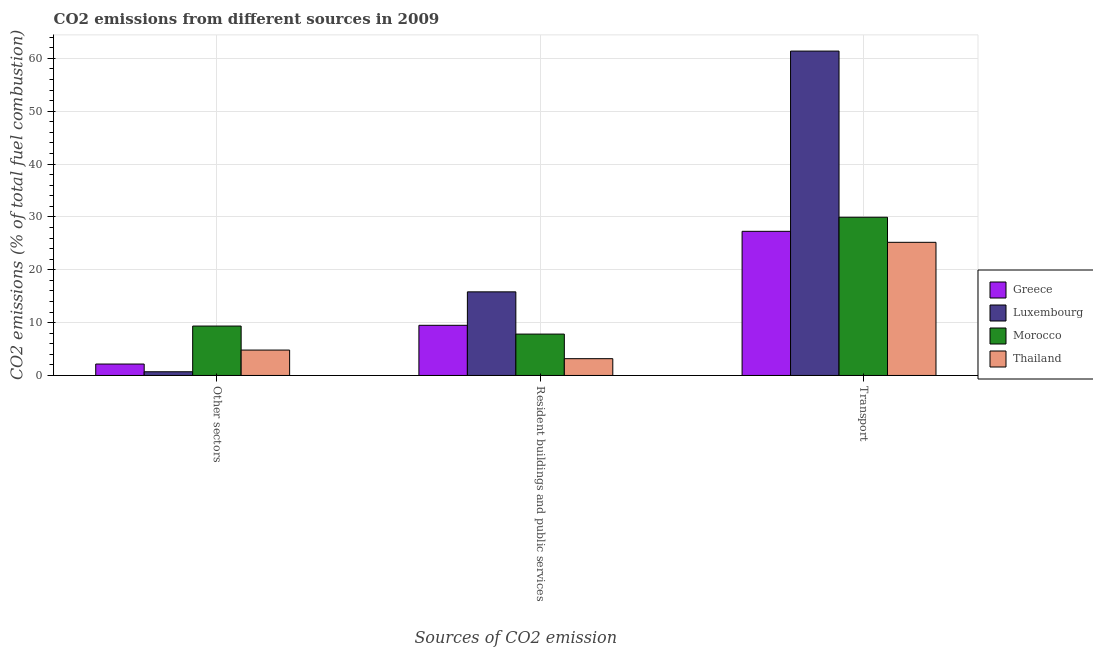How many different coloured bars are there?
Provide a succinct answer. 4. Are the number of bars per tick equal to the number of legend labels?
Your response must be concise. Yes. How many bars are there on the 2nd tick from the right?
Provide a short and direct response. 4. What is the label of the 2nd group of bars from the left?
Keep it short and to the point. Resident buildings and public services. What is the percentage of co2 emissions from transport in Luxembourg?
Ensure brevity in your answer.  61.36. Across all countries, what is the maximum percentage of co2 emissions from transport?
Provide a short and direct response. 61.36. Across all countries, what is the minimum percentage of co2 emissions from resident buildings and public services?
Make the answer very short. 3.17. In which country was the percentage of co2 emissions from transport maximum?
Keep it short and to the point. Luxembourg. In which country was the percentage of co2 emissions from resident buildings and public services minimum?
Offer a very short reply. Thailand. What is the total percentage of co2 emissions from other sectors in the graph?
Provide a succinct answer. 17.01. What is the difference between the percentage of co2 emissions from transport in Morocco and that in Thailand?
Your response must be concise. 4.74. What is the difference between the percentage of co2 emissions from resident buildings and public services in Greece and the percentage of co2 emissions from other sectors in Luxembourg?
Give a very brief answer. 8.79. What is the average percentage of co2 emissions from other sectors per country?
Offer a very short reply. 4.25. What is the difference between the percentage of co2 emissions from transport and percentage of co2 emissions from other sectors in Morocco?
Give a very brief answer. 20.58. What is the ratio of the percentage of co2 emissions from transport in Luxembourg to that in Thailand?
Ensure brevity in your answer.  2.44. Is the percentage of co2 emissions from other sectors in Morocco less than that in Thailand?
Your answer should be compact. No. What is the difference between the highest and the second highest percentage of co2 emissions from other sectors?
Ensure brevity in your answer.  4.54. What is the difference between the highest and the lowest percentage of co2 emissions from transport?
Keep it short and to the point. 36.17. Is the sum of the percentage of co2 emissions from resident buildings and public services in Luxembourg and Morocco greater than the maximum percentage of co2 emissions from other sectors across all countries?
Your answer should be very brief. Yes. What does the 3rd bar from the left in Transport represents?
Offer a very short reply. Morocco. What does the 4th bar from the right in Resident buildings and public services represents?
Offer a very short reply. Greece. Is it the case that in every country, the sum of the percentage of co2 emissions from other sectors and percentage of co2 emissions from resident buildings and public services is greater than the percentage of co2 emissions from transport?
Offer a terse response. No. How many bars are there?
Your answer should be very brief. 12. Are all the bars in the graph horizontal?
Give a very brief answer. No. What is the difference between two consecutive major ticks on the Y-axis?
Give a very brief answer. 10. Are the values on the major ticks of Y-axis written in scientific E-notation?
Your answer should be very brief. No. Does the graph contain grids?
Ensure brevity in your answer.  Yes. What is the title of the graph?
Your answer should be compact. CO2 emissions from different sources in 2009. Does "Pakistan" appear as one of the legend labels in the graph?
Keep it short and to the point. No. What is the label or title of the X-axis?
Provide a succinct answer. Sources of CO2 emission. What is the label or title of the Y-axis?
Your answer should be very brief. CO2 emissions (% of total fuel combustion). What is the CO2 emissions (% of total fuel combustion) in Greece in Other sectors?
Ensure brevity in your answer.  2.16. What is the CO2 emissions (% of total fuel combustion) in Luxembourg in Other sectors?
Offer a terse response. 0.7. What is the CO2 emissions (% of total fuel combustion) of Morocco in Other sectors?
Provide a short and direct response. 9.35. What is the CO2 emissions (% of total fuel combustion) in Thailand in Other sectors?
Ensure brevity in your answer.  4.8. What is the CO2 emissions (% of total fuel combustion) of Greece in Resident buildings and public services?
Your answer should be very brief. 9.49. What is the CO2 emissions (% of total fuel combustion) of Luxembourg in Resident buildings and public services?
Your response must be concise. 15.82. What is the CO2 emissions (% of total fuel combustion) of Morocco in Resident buildings and public services?
Ensure brevity in your answer.  7.83. What is the CO2 emissions (% of total fuel combustion) of Thailand in Resident buildings and public services?
Give a very brief answer. 3.17. What is the CO2 emissions (% of total fuel combustion) in Greece in Transport?
Offer a very short reply. 27.27. What is the CO2 emissions (% of total fuel combustion) in Luxembourg in Transport?
Offer a terse response. 61.36. What is the CO2 emissions (% of total fuel combustion) of Morocco in Transport?
Offer a terse response. 29.93. What is the CO2 emissions (% of total fuel combustion) of Thailand in Transport?
Keep it short and to the point. 25.19. Across all Sources of CO2 emission, what is the maximum CO2 emissions (% of total fuel combustion) of Greece?
Ensure brevity in your answer.  27.27. Across all Sources of CO2 emission, what is the maximum CO2 emissions (% of total fuel combustion) in Luxembourg?
Your answer should be compact. 61.36. Across all Sources of CO2 emission, what is the maximum CO2 emissions (% of total fuel combustion) in Morocco?
Provide a short and direct response. 29.93. Across all Sources of CO2 emission, what is the maximum CO2 emissions (% of total fuel combustion) in Thailand?
Keep it short and to the point. 25.19. Across all Sources of CO2 emission, what is the minimum CO2 emissions (% of total fuel combustion) of Greece?
Your answer should be very brief. 2.16. Across all Sources of CO2 emission, what is the minimum CO2 emissions (% of total fuel combustion) in Luxembourg?
Give a very brief answer. 0.7. Across all Sources of CO2 emission, what is the minimum CO2 emissions (% of total fuel combustion) in Morocco?
Make the answer very short. 7.83. Across all Sources of CO2 emission, what is the minimum CO2 emissions (% of total fuel combustion) of Thailand?
Provide a short and direct response. 3.17. What is the total CO2 emissions (% of total fuel combustion) in Greece in the graph?
Your response must be concise. 38.92. What is the total CO2 emissions (% of total fuel combustion) in Luxembourg in the graph?
Make the answer very short. 77.88. What is the total CO2 emissions (% of total fuel combustion) of Morocco in the graph?
Give a very brief answer. 47.1. What is the total CO2 emissions (% of total fuel combustion) of Thailand in the graph?
Your response must be concise. 33.16. What is the difference between the CO2 emissions (% of total fuel combustion) of Greece in Other sectors and that in Resident buildings and public services?
Offer a very short reply. -7.33. What is the difference between the CO2 emissions (% of total fuel combustion) of Luxembourg in Other sectors and that in Resident buildings and public services?
Offer a terse response. -15.12. What is the difference between the CO2 emissions (% of total fuel combustion) in Morocco in Other sectors and that in Resident buildings and public services?
Provide a short and direct response. 1.52. What is the difference between the CO2 emissions (% of total fuel combustion) of Thailand in Other sectors and that in Resident buildings and public services?
Your response must be concise. 1.63. What is the difference between the CO2 emissions (% of total fuel combustion) of Greece in Other sectors and that in Transport?
Keep it short and to the point. -25.11. What is the difference between the CO2 emissions (% of total fuel combustion) of Luxembourg in Other sectors and that in Transport?
Your answer should be very brief. -60.66. What is the difference between the CO2 emissions (% of total fuel combustion) in Morocco in Other sectors and that in Transport?
Your answer should be very brief. -20.58. What is the difference between the CO2 emissions (% of total fuel combustion) in Thailand in Other sectors and that in Transport?
Make the answer very short. -20.38. What is the difference between the CO2 emissions (% of total fuel combustion) in Greece in Resident buildings and public services and that in Transport?
Your response must be concise. -17.78. What is the difference between the CO2 emissions (% of total fuel combustion) in Luxembourg in Resident buildings and public services and that in Transport?
Your answer should be compact. -45.55. What is the difference between the CO2 emissions (% of total fuel combustion) of Morocco in Resident buildings and public services and that in Transport?
Provide a short and direct response. -22.1. What is the difference between the CO2 emissions (% of total fuel combustion) in Thailand in Resident buildings and public services and that in Transport?
Offer a very short reply. -22.01. What is the difference between the CO2 emissions (% of total fuel combustion) of Greece in Other sectors and the CO2 emissions (% of total fuel combustion) of Luxembourg in Resident buildings and public services?
Offer a very short reply. -13.65. What is the difference between the CO2 emissions (% of total fuel combustion) in Greece in Other sectors and the CO2 emissions (% of total fuel combustion) in Morocco in Resident buildings and public services?
Provide a succinct answer. -5.67. What is the difference between the CO2 emissions (% of total fuel combustion) in Greece in Other sectors and the CO2 emissions (% of total fuel combustion) in Thailand in Resident buildings and public services?
Keep it short and to the point. -1.01. What is the difference between the CO2 emissions (% of total fuel combustion) in Luxembourg in Other sectors and the CO2 emissions (% of total fuel combustion) in Morocco in Resident buildings and public services?
Offer a terse response. -7.13. What is the difference between the CO2 emissions (% of total fuel combustion) in Luxembourg in Other sectors and the CO2 emissions (% of total fuel combustion) in Thailand in Resident buildings and public services?
Offer a terse response. -2.47. What is the difference between the CO2 emissions (% of total fuel combustion) in Morocco in Other sectors and the CO2 emissions (% of total fuel combustion) in Thailand in Resident buildings and public services?
Make the answer very short. 6.17. What is the difference between the CO2 emissions (% of total fuel combustion) of Greece in Other sectors and the CO2 emissions (% of total fuel combustion) of Luxembourg in Transport?
Make the answer very short. -59.2. What is the difference between the CO2 emissions (% of total fuel combustion) in Greece in Other sectors and the CO2 emissions (% of total fuel combustion) in Morocco in Transport?
Your answer should be very brief. -27.77. What is the difference between the CO2 emissions (% of total fuel combustion) in Greece in Other sectors and the CO2 emissions (% of total fuel combustion) in Thailand in Transport?
Provide a short and direct response. -23.03. What is the difference between the CO2 emissions (% of total fuel combustion) of Luxembourg in Other sectors and the CO2 emissions (% of total fuel combustion) of Morocco in Transport?
Ensure brevity in your answer.  -29.23. What is the difference between the CO2 emissions (% of total fuel combustion) of Luxembourg in Other sectors and the CO2 emissions (% of total fuel combustion) of Thailand in Transport?
Provide a succinct answer. -24.49. What is the difference between the CO2 emissions (% of total fuel combustion) of Morocco in Other sectors and the CO2 emissions (% of total fuel combustion) of Thailand in Transport?
Offer a terse response. -15.84. What is the difference between the CO2 emissions (% of total fuel combustion) of Greece in Resident buildings and public services and the CO2 emissions (% of total fuel combustion) of Luxembourg in Transport?
Provide a succinct answer. -51.87. What is the difference between the CO2 emissions (% of total fuel combustion) of Greece in Resident buildings and public services and the CO2 emissions (% of total fuel combustion) of Morocco in Transport?
Offer a terse response. -20.44. What is the difference between the CO2 emissions (% of total fuel combustion) in Greece in Resident buildings and public services and the CO2 emissions (% of total fuel combustion) in Thailand in Transport?
Make the answer very short. -15.7. What is the difference between the CO2 emissions (% of total fuel combustion) in Luxembourg in Resident buildings and public services and the CO2 emissions (% of total fuel combustion) in Morocco in Transport?
Provide a succinct answer. -14.11. What is the difference between the CO2 emissions (% of total fuel combustion) in Luxembourg in Resident buildings and public services and the CO2 emissions (% of total fuel combustion) in Thailand in Transport?
Your answer should be very brief. -9.37. What is the difference between the CO2 emissions (% of total fuel combustion) in Morocco in Resident buildings and public services and the CO2 emissions (% of total fuel combustion) in Thailand in Transport?
Your response must be concise. -17.36. What is the average CO2 emissions (% of total fuel combustion) in Greece per Sources of CO2 emission?
Provide a short and direct response. 12.97. What is the average CO2 emissions (% of total fuel combustion) of Luxembourg per Sources of CO2 emission?
Make the answer very short. 25.96. What is the average CO2 emissions (% of total fuel combustion) in Morocco per Sources of CO2 emission?
Keep it short and to the point. 15.7. What is the average CO2 emissions (% of total fuel combustion) of Thailand per Sources of CO2 emission?
Ensure brevity in your answer.  11.05. What is the difference between the CO2 emissions (% of total fuel combustion) of Greece and CO2 emissions (% of total fuel combustion) of Luxembourg in Other sectors?
Your answer should be very brief. 1.46. What is the difference between the CO2 emissions (% of total fuel combustion) of Greece and CO2 emissions (% of total fuel combustion) of Morocco in Other sectors?
Give a very brief answer. -7.18. What is the difference between the CO2 emissions (% of total fuel combustion) of Greece and CO2 emissions (% of total fuel combustion) of Thailand in Other sectors?
Your response must be concise. -2.64. What is the difference between the CO2 emissions (% of total fuel combustion) in Luxembourg and CO2 emissions (% of total fuel combustion) in Morocco in Other sectors?
Keep it short and to the point. -8.65. What is the difference between the CO2 emissions (% of total fuel combustion) in Luxembourg and CO2 emissions (% of total fuel combustion) in Thailand in Other sectors?
Offer a terse response. -4.1. What is the difference between the CO2 emissions (% of total fuel combustion) of Morocco and CO2 emissions (% of total fuel combustion) of Thailand in Other sectors?
Offer a very short reply. 4.54. What is the difference between the CO2 emissions (% of total fuel combustion) in Greece and CO2 emissions (% of total fuel combustion) in Luxembourg in Resident buildings and public services?
Give a very brief answer. -6.33. What is the difference between the CO2 emissions (% of total fuel combustion) of Greece and CO2 emissions (% of total fuel combustion) of Morocco in Resident buildings and public services?
Your response must be concise. 1.66. What is the difference between the CO2 emissions (% of total fuel combustion) in Greece and CO2 emissions (% of total fuel combustion) in Thailand in Resident buildings and public services?
Make the answer very short. 6.31. What is the difference between the CO2 emissions (% of total fuel combustion) of Luxembourg and CO2 emissions (% of total fuel combustion) of Morocco in Resident buildings and public services?
Provide a succinct answer. 7.99. What is the difference between the CO2 emissions (% of total fuel combustion) in Luxembourg and CO2 emissions (% of total fuel combustion) in Thailand in Resident buildings and public services?
Your answer should be compact. 12.64. What is the difference between the CO2 emissions (% of total fuel combustion) of Morocco and CO2 emissions (% of total fuel combustion) of Thailand in Resident buildings and public services?
Offer a very short reply. 4.65. What is the difference between the CO2 emissions (% of total fuel combustion) in Greece and CO2 emissions (% of total fuel combustion) in Luxembourg in Transport?
Ensure brevity in your answer.  -34.09. What is the difference between the CO2 emissions (% of total fuel combustion) of Greece and CO2 emissions (% of total fuel combustion) of Morocco in Transport?
Offer a terse response. -2.66. What is the difference between the CO2 emissions (% of total fuel combustion) in Greece and CO2 emissions (% of total fuel combustion) in Thailand in Transport?
Offer a terse response. 2.08. What is the difference between the CO2 emissions (% of total fuel combustion) in Luxembourg and CO2 emissions (% of total fuel combustion) in Morocco in Transport?
Your answer should be very brief. 31.43. What is the difference between the CO2 emissions (% of total fuel combustion) in Luxembourg and CO2 emissions (% of total fuel combustion) in Thailand in Transport?
Offer a terse response. 36.17. What is the difference between the CO2 emissions (% of total fuel combustion) in Morocco and CO2 emissions (% of total fuel combustion) in Thailand in Transport?
Make the answer very short. 4.74. What is the ratio of the CO2 emissions (% of total fuel combustion) of Greece in Other sectors to that in Resident buildings and public services?
Ensure brevity in your answer.  0.23. What is the ratio of the CO2 emissions (% of total fuel combustion) in Luxembourg in Other sectors to that in Resident buildings and public services?
Offer a very short reply. 0.04. What is the ratio of the CO2 emissions (% of total fuel combustion) of Morocco in Other sectors to that in Resident buildings and public services?
Provide a short and direct response. 1.19. What is the ratio of the CO2 emissions (% of total fuel combustion) of Thailand in Other sectors to that in Resident buildings and public services?
Keep it short and to the point. 1.51. What is the ratio of the CO2 emissions (% of total fuel combustion) of Greece in Other sectors to that in Transport?
Provide a short and direct response. 0.08. What is the ratio of the CO2 emissions (% of total fuel combustion) in Luxembourg in Other sectors to that in Transport?
Offer a very short reply. 0.01. What is the ratio of the CO2 emissions (% of total fuel combustion) of Morocco in Other sectors to that in Transport?
Your answer should be very brief. 0.31. What is the ratio of the CO2 emissions (% of total fuel combustion) of Thailand in Other sectors to that in Transport?
Offer a very short reply. 0.19. What is the ratio of the CO2 emissions (% of total fuel combustion) of Greece in Resident buildings and public services to that in Transport?
Your response must be concise. 0.35. What is the ratio of the CO2 emissions (% of total fuel combustion) in Luxembourg in Resident buildings and public services to that in Transport?
Make the answer very short. 0.26. What is the ratio of the CO2 emissions (% of total fuel combustion) of Morocco in Resident buildings and public services to that in Transport?
Give a very brief answer. 0.26. What is the ratio of the CO2 emissions (% of total fuel combustion) of Thailand in Resident buildings and public services to that in Transport?
Provide a succinct answer. 0.13. What is the difference between the highest and the second highest CO2 emissions (% of total fuel combustion) of Greece?
Keep it short and to the point. 17.78. What is the difference between the highest and the second highest CO2 emissions (% of total fuel combustion) in Luxembourg?
Your response must be concise. 45.55. What is the difference between the highest and the second highest CO2 emissions (% of total fuel combustion) of Morocco?
Make the answer very short. 20.58. What is the difference between the highest and the second highest CO2 emissions (% of total fuel combustion) in Thailand?
Provide a succinct answer. 20.38. What is the difference between the highest and the lowest CO2 emissions (% of total fuel combustion) in Greece?
Your answer should be very brief. 25.11. What is the difference between the highest and the lowest CO2 emissions (% of total fuel combustion) in Luxembourg?
Keep it short and to the point. 60.66. What is the difference between the highest and the lowest CO2 emissions (% of total fuel combustion) of Morocco?
Your response must be concise. 22.1. What is the difference between the highest and the lowest CO2 emissions (% of total fuel combustion) in Thailand?
Provide a short and direct response. 22.01. 